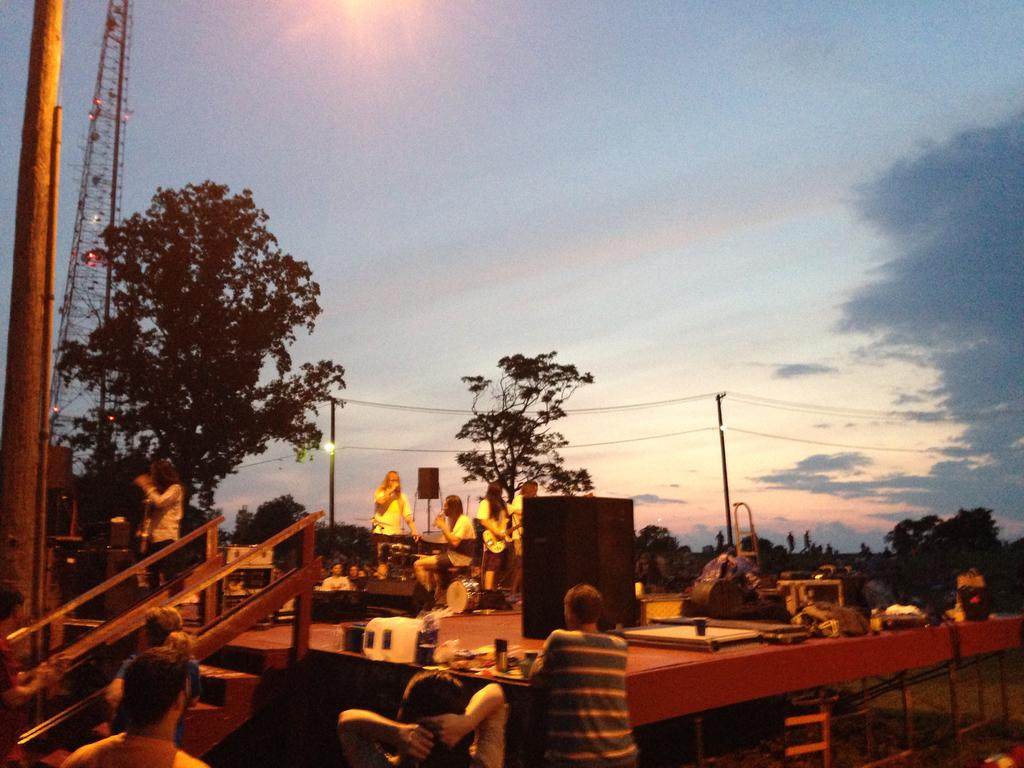How many people can be seen in the image? There are people in the image, but the exact number is not specified. What objects are present in the image that might be used for carrying items? There are bags in the image that can be used for carrying items. What type of equipment is visible in the image that might be used for amplifying sound? There are speakers in the image that can be used for amplifying sound. What type of structures can be seen in the image that might be used for supporting objects or providing stability? There are poles in the image that can be used for supporting objects or providing stability. What type of natural elements can be seen in the image? There are trees in the image, which are natural elements. What type of infrastructure can be seen in the image that might be used for transmitting electricity or communication signals? There are wires in the image that can be used for transmitting electricity or communication signals. What type of lighting can be seen in the image? There are lights in the image that provide illumination. What type of tall structure can be seen in the image? There is a tower in the image that is a tall structure. What type of atmospheric elements can be seen in the image? There are clouds in the image, which are atmospheric elements. What type of background can be seen in the image? The sky is visible in the image, which serves as the background. What type of architectural feature can be seen in the image that might be used for accessing different levels or areas? There are stairs in the image that can be used for accessing different levels or areas. Where is the sofa located in the image? There is no sofa present in the image. What type of poison can be seen in the image? There is no poison present in the image. What type of police activity can be seen in the image? There is no police activity present in the image. 